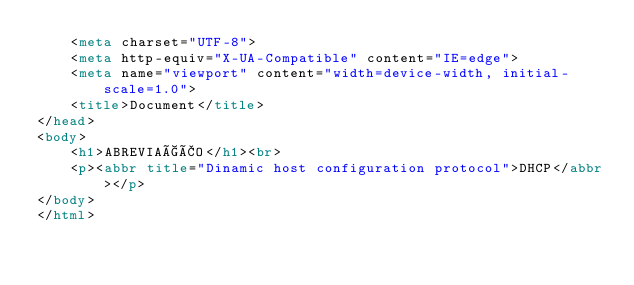<code> <loc_0><loc_0><loc_500><loc_500><_HTML_>    <meta charset="UTF-8">
    <meta http-equiv="X-UA-Compatible" content="IE=edge">
    <meta name="viewport" content="width=device-width, initial-scale=1.0">
    <title>Document</title>
</head>
<body>
    <h1>ABREVIAÇÃO</h1><br>
    <p><abbr title="Dinamic host configuration protocol">DHCP</abbr></p>
</body>
</html></code> 